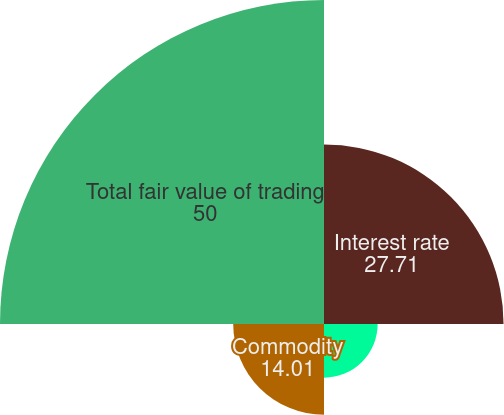Convert chart to OTSL. <chart><loc_0><loc_0><loc_500><loc_500><pie_chart><fcel>Interest rate<fcel>Foreign exchange (b)<fcel>Commodity<fcel>Total fair value of trading<nl><fcel>27.71%<fcel>8.28%<fcel>14.01%<fcel>50.0%<nl></chart> 